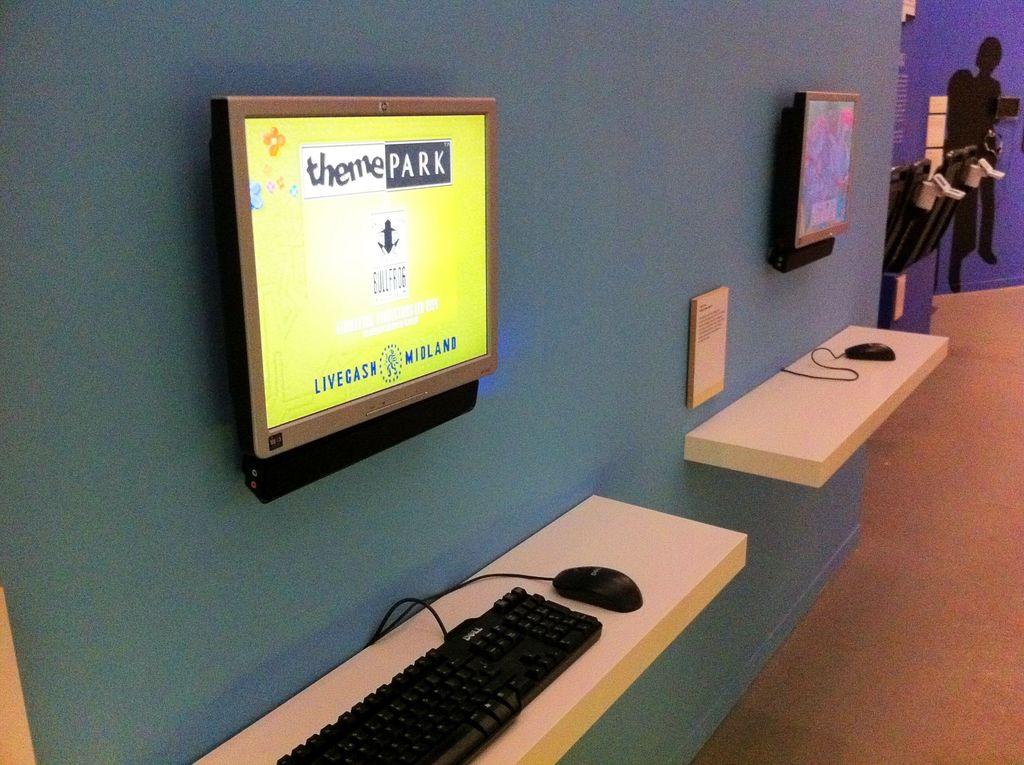What are the two words on top of the yellow screen?
Your response must be concise. Theme park. What are the two words on the bottom of the screen?
Make the answer very short. Livecash midland. 